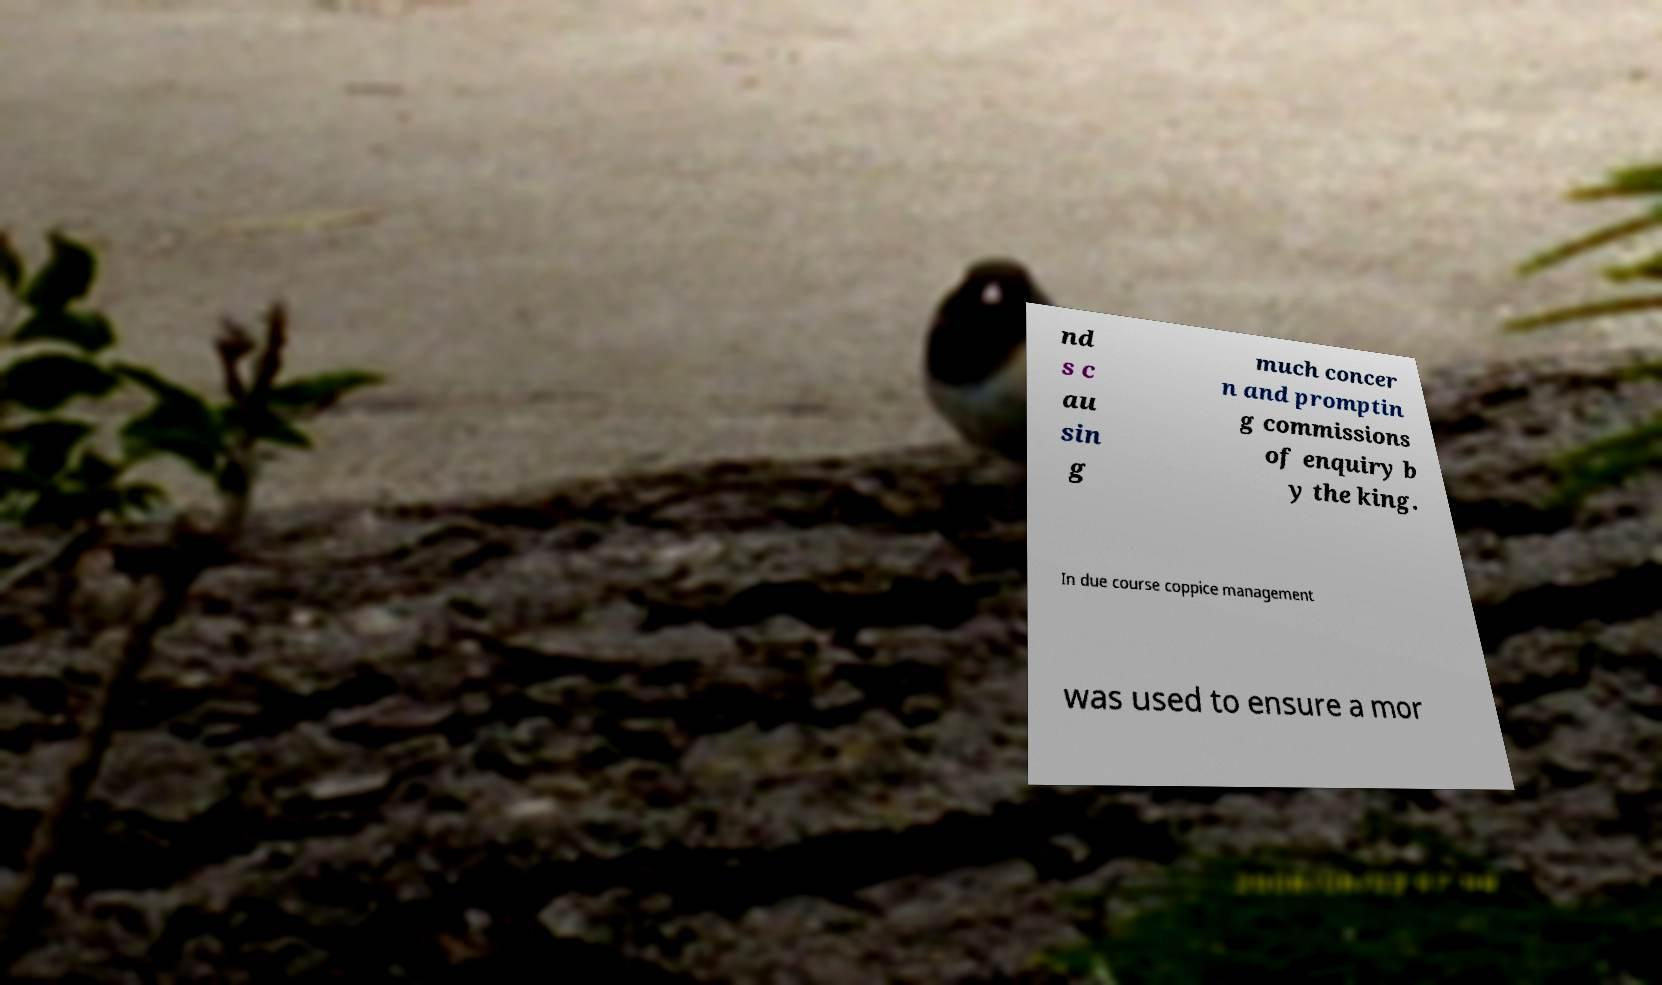I need the written content from this picture converted into text. Can you do that? nd s c au sin g much concer n and promptin g commissions of enquiry b y the king. In due course coppice management was used to ensure a mor 